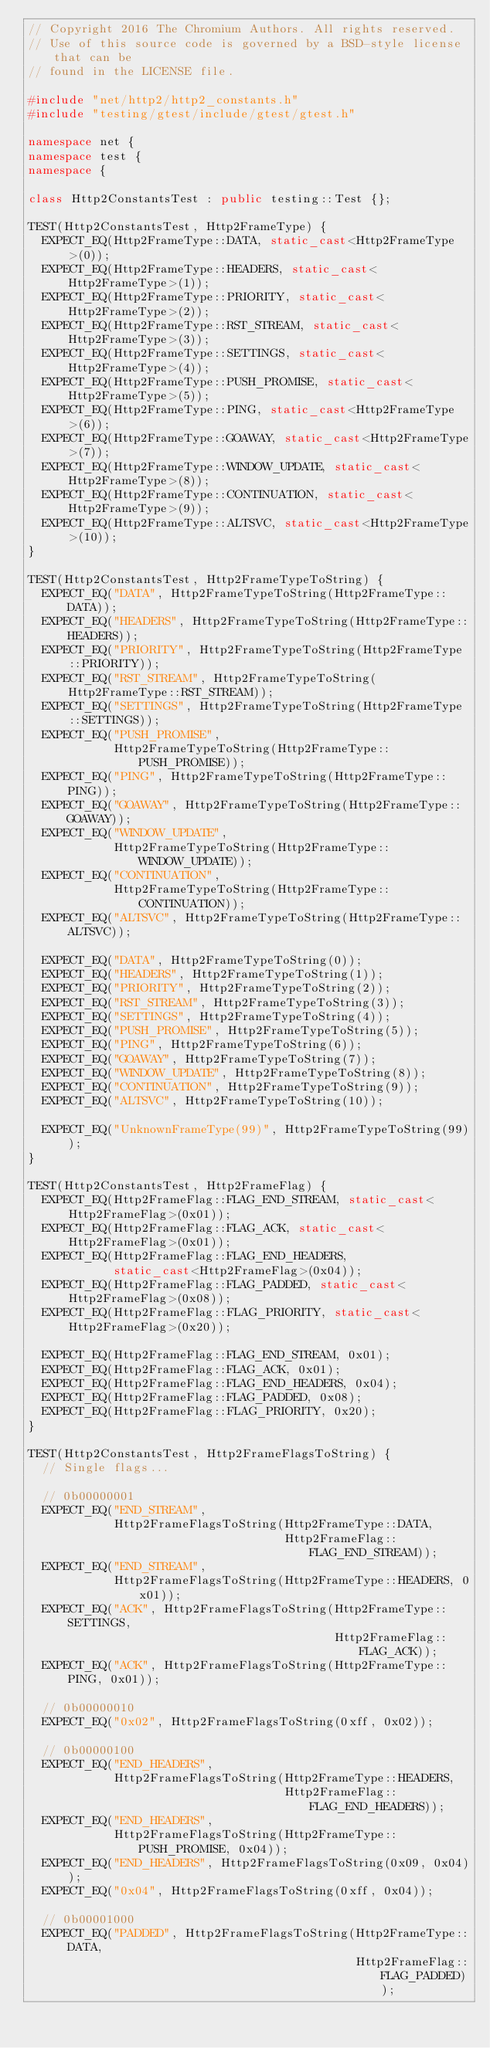Convert code to text. <code><loc_0><loc_0><loc_500><loc_500><_C++_>// Copyright 2016 The Chromium Authors. All rights reserved.
// Use of this source code is governed by a BSD-style license that can be
// found in the LICENSE file.

#include "net/http2/http2_constants.h"
#include "testing/gtest/include/gtest/gtest.h"

namespace net {
namespace test {
namespace {

class Http2ConstantsTest : public testing::Test {};

TEST(Http2ConstantsTest, Http2FrameType) {
  EXPECT_EQ(Http2FrameType::DATA, static_cast<Http2FrameType>(0));
  EXPECT_EQ(Http2FrameType::HEADERS, static_cast<Http2FrameType>(1));
  EXPECT_EQ(Http2FrameType::PRIORITY, static_cast<Http2FrameType>(2));
  EXPECT_EQ(Http2FrameType::RST_STREAM, static_cast<Http2FrameType>(3));
  EXPECT_EQ(Http2FrameType::SETTINGS, static_cast<Http2FrameType>(4));
  EXPECT_EQ(Http2FrameType::PUSH_PROMISE, static_cast<Http2FrameType>(5));
  EXPECT_EQ(Http2FrameType::PING, static_cast<Http2FrameType>(6));
  EXPECT_EQ(Http2FrameType::GOAWAY, static_cast<Http2FrameType>(7));
  EXPECT_EQ(Http2FrameType::WINDOW_UPDATE, static_cast<Http2FrameType>(8));
  EXPECT_EQ(Http2FrameType::CONTINUATION, static_cast<Http2FrameType>(9));
  EXPECT_EQ(Http2FrameType::ALTSVC, static_cast<Http2FrameType>(10));
}

TEST(Http2ConstantsTest, Http2FrameTypeToString) {
  EXPECT_EQ("DATA", Http2FrameTypeToString(Http2FrameType::DATA));
  EXPECT_EQ("HEADERS", Http2FrameTypeToString(Http2FrameType::HEADERS));
  EXPECT_EQ("PRIORITY", Http2FrameTypeToString(Http2FrameType::PRIORITY));
  EXPECT_EQ("RST_STREAM", Http2FrameTypeToString(Http2FrameType::RST_STREAM));
  EXPECT_EQ("SETTINGS", Http2FrameTypeToString(Http2FrameType::SETTINGS));
  EXPECT_EQ("PUSH_PROMISE",
            Http2FrameTypeToString(Http2FrameType::PUSH_PROMISE));
  EXPECT_EQ("PING", Http2FrameTypeToString(Http2FrameType::PING));
  EXPECT_EQ("GOAWAY", Http2FrameTypeToString(Http2FrameType::GOAWAY));
  EXPECT_EQ("WINDOW_UPDATE",
            Http2FrameTypeToString(Http2FrameType::WINDOW_UPDATE));
  EXPECT_EQ("CONTINUATION",
            Http2FrameTypeToString(Http2FrameType::CONTINUATION));
  EXPECT_EQ("ALTSVC", Http2FrameTypeToString(Http2FrameType::ALTSVC));

  EXPECT_EQ("DATA", Http2FrameTypeToString(0));
  EXPECT_EQ("HEADERS", Http2FrameTypeToString(1));
  EXPECT_EQ("PRIORITY", Http2FrameTypeToString(2));
  EXPECT_EQ("RST_STREAM", Http2FrameTypeToString(3));
  EXPECT_EQ("SETTINGS", Http2FrameTypeToString(4));
  EXPECT_EQ("PUSH_PROMISE", Http2FrameTypeToString(5));
  EXPECT_EQ("PING", Http2FrameTypeToString(6));
  EXPECT_EQ("GOAWAY", Http2FrameTypeToString(7));
  EXPECT_EQ("WINDOW_UPDATE", Http2FrameTypeToString(8));
  EXPECT_EQ("CONTINUATION", Http2FrameTypeToString(9));
  EXPECT_EQ("ALTSVC", Http2FrameTypeToString(10));

  EXPECT_EQ("UnknownFrameType(99)", Http2FrameTypeToString(99));
}

TEST(Http2ConstantsTest, Http2FrameFlag) {
  EXPECT_EQ(Http2FrameFlag::FLAG_END_STREAM, static_cast<Http2FrameFlag>(0x01));
  EXPECT_EQ(Http2FrameFlag::FLAG_ACK, static_cast<Http2FrameFlag>(0x01));
  EXPECT_EQ(Http2FrameFlag::FLAG_END_HEADERS,
            static_cast<Http2FrameFlag>(0x04));
  EXPECT_EQ(Http2FrameFlag::FLAG_PADDED, static_cast<Http2FrameFlag>(0x08));
  EXPECT_EQ(Http2FrameFlag::FLAG_PRIORITY, static_cast<Http2FrameFlag>(0x20));

  EXPECT_EQ(Http2FrameFlag::FLAG_END_STREAM, 0x01);
  EXPECT_EQ(Http2FrameFlag::FLAG_ACK, 0x01);
  EXPECT_EQ(Http2FrameFlag::FLAG_END_HEADERS, 0x04);
  EXPECT_EQ(Http2FrameFlag::FLAG_PADDED, 0x08);
  EXPECT_EQ(Http2FrameFlag::FLAG_PRIORITY, 0x20);
}

TEST(Http2ConstantsTest, Http2FrameFlagsToString) {
  // Single flags...

  // 0b00000001
  EXPECT_EQ("END_STREAM",
            Http2FrameFlagsToString(Http2FrameType::DATA,
                                    Http2FrameFlag::FLAG_END_STREAM));
  EXPECT_EQ("END_STREAM",
            Http2FrameFlagsToString(Http2FrameType::HEADERS, 0x01));
  EXPECT_EQ("ACK", Http2FrameFlagsToString(Http2FrameType::SETTINGS,
                                           Http2FrameFlag::FLAG_ACK));
  EXPECT_EQ("ACK", Http2FrameFlagsToString(Http2FrameType::PING, 0x01));

  // 0b00000010
  EXPECT_EQ("0x02", Http2FrameFlagsToString(0xff, 0x02));

  // 0b00000100
  EXPECT_EQ("END_HEADERS",
            Http2FrameFlagsToString(Http2FrameType::HEADERS,
                                    Http2FrameFlag::FLAG_END_HEADERS));
  EXPECT_EQ("END_HEADERS",
            Http2FrameFlagsToString(Http2FrameType::PUSH_PROMISE, 0x04));
  EXPECT_EQ("END_HEADERS", Http2FrameFlagsToString(0x09, 0x04));
  EXPECT_EQ("0x04", Http2FrameFlagsToString(0xff, 0x04));

  // 0b00001000
  EXPECT_EQ("PADDED", Http2FrameFlagsToString(Http2FrameType::DATA,
                                              Http2FrameFlag::FLAG_PADDED));</code> 